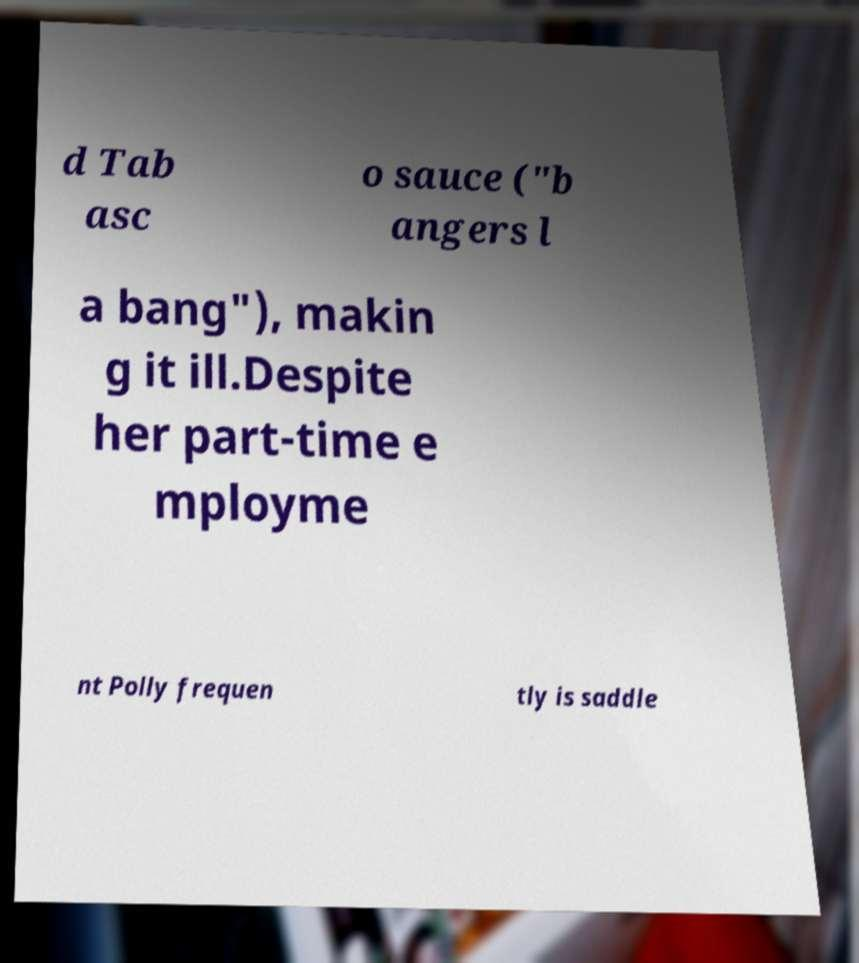There's text embedded in this image that I need extracted. Can you transcribe it verbatim? d Tab asc o sauce ("b angers l a bang"), makin g it ill.Despite her part-time e mployme nt Polly frequen tly is saddle 